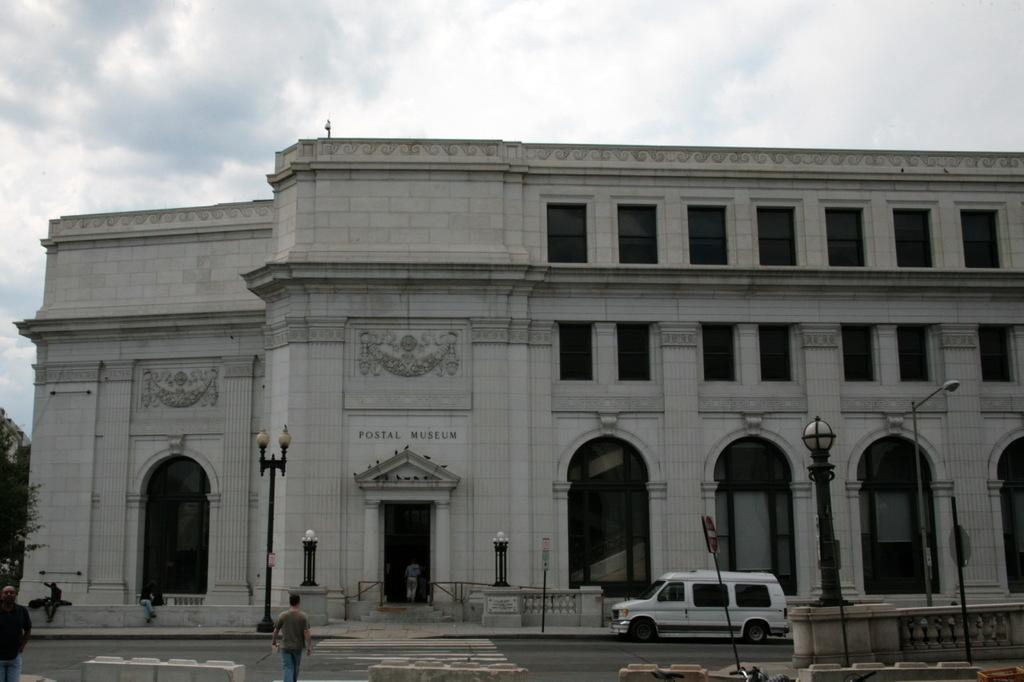<image>
Give a short and clear explanation of the subsequent image. A museum is adorned with letters spelling out "Postal Museum." 